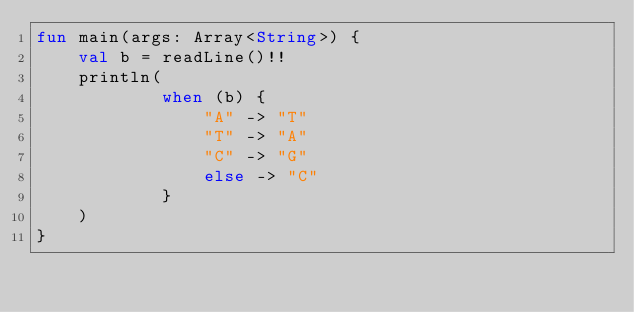<code> <loc_0><loc_0><loc_500><loc_500><_Kotlin_>fun main(args: Array<String>) {
    val b = readLine()!!
    println(
            when (b) {
                "A" -> "T"
                "T" -> "A"
                "C" -> "G"
                else -> "C"
            }
    )
}
</code> 